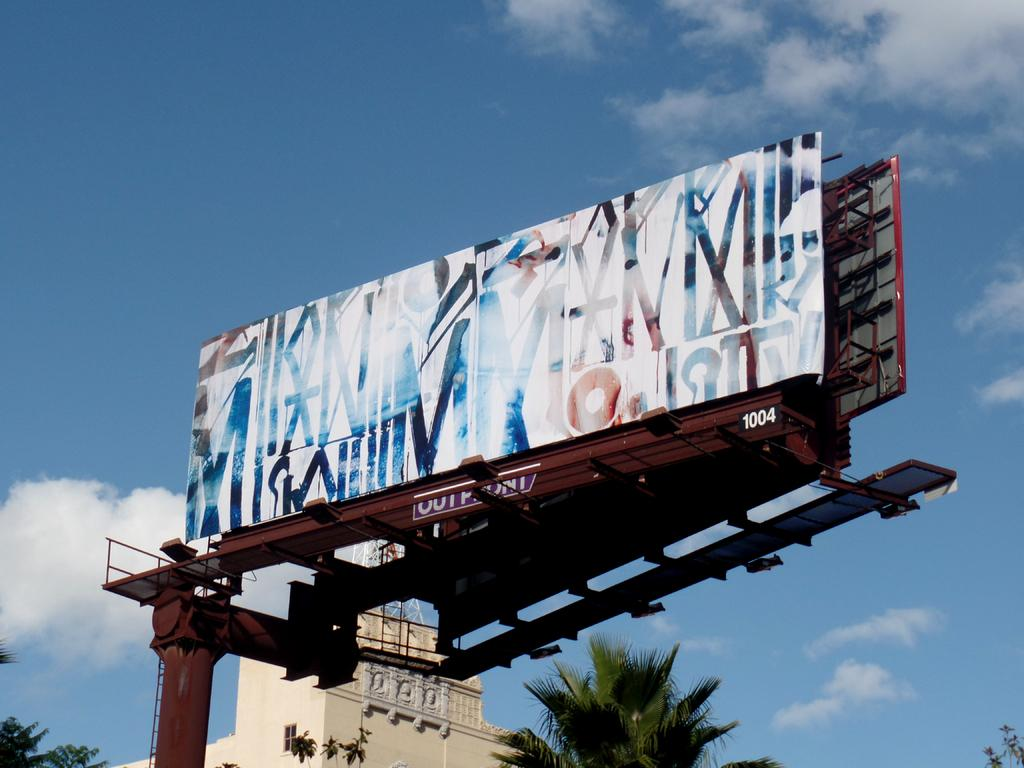<image>
Describe the image concisely. A billboard sits on a frame that is numbered 1004. 